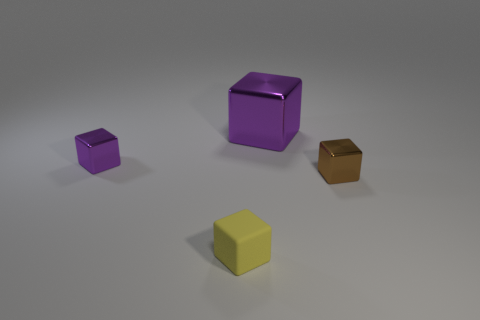What is the material of the small thing behind the small brown cube?
Offer a very short reply. Metal. Is there any other thing that is the same color as the rubber object?
Your answer should be compact. No. What is the shape of the big shiny object?
Make the answer very short. Cube. How many small cubes are both right of the yellow rubber object and left of the yellow cube?
Ensure brevity in your answer.  0. Is the color of the big object the same as the small matte block?
Your answer should be very brief. No. There is another large purple object that is the same shape as the matte thing; what is its material?
Give a very brief answer. Metal. Are there any other things that are the same material as the tiny brown thing?
Keep it short and to the point. Yes. Are there an equal number of big purple things that are in front of the large thing and metallic things that are in front of the small purple cube?
Provide a short and direct response. No. Is the tiny brown object made of the same material as the tiny purple thing?
Your response must be concise. Yes. How many green things are either rubber blocks or small shiny cubes?
Make the answer very short. 0. 